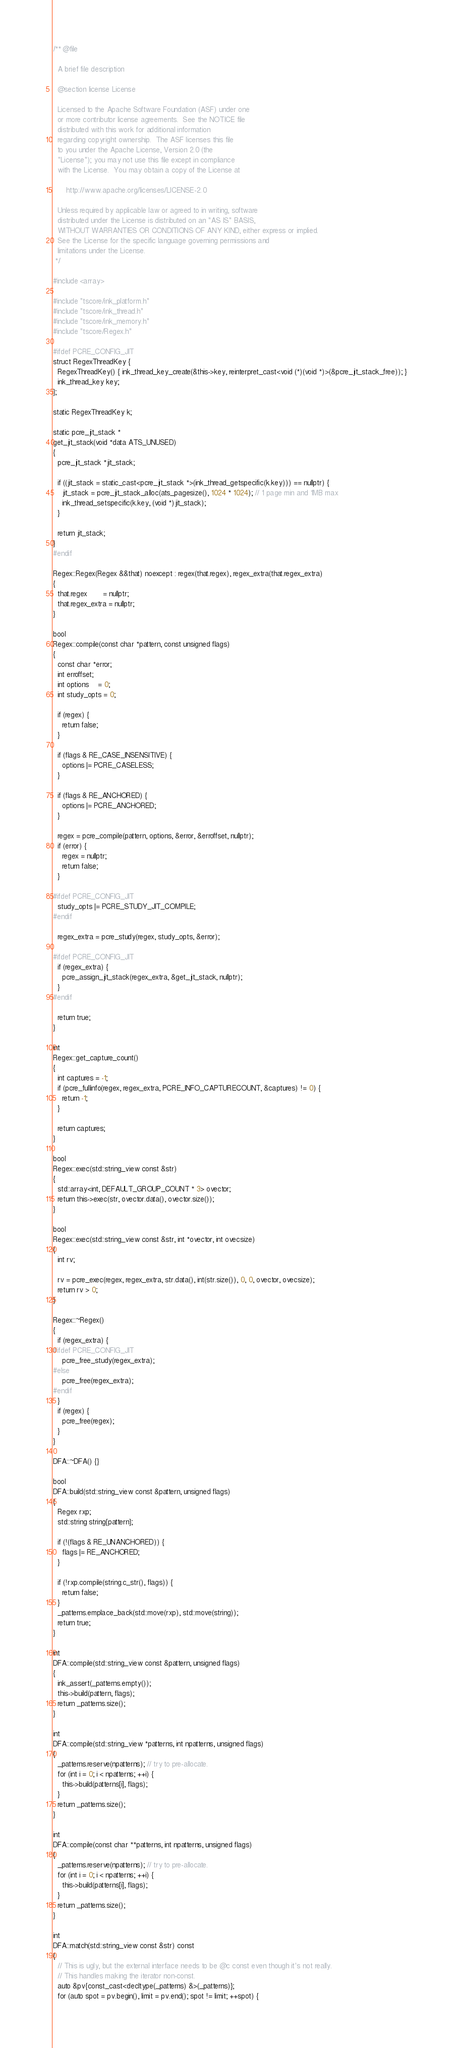<code> <loc_0><loc_0><loc_500><loc_500><_C++_>/** @file

  A brief file description

  @section license License

  Licensed to the Apache Software Foundation (ASF) under one
  or more contributor license agreements.  See the NOTICE file
  distributed with this work for additional information
  regarding copyright ownership.  The ASF licenses this file
  to you under the Apache License, Version 2.0 (the
  "License"); you may not use this file except in compliance
  with the License.  You may obtain a copy of the License at

      http://www.apache.org/licenses/LICENSE-2.0

  Unless required by applicable law or agreed to in writing, software
  distributed under the License is distributed on an "AS IS" BASIS,
  WITHOUT WARRANTIES OR CONDITIONS OF ANY KIND, either express or implied.
  See the License for the specific language governing permissions and
  limitations under the License.
 */

#include <array>

#include "tscore/ink_platform.h"
#include "tscore/ink_thread.h"
#include "tscore/ink_memory.h"
#include "tscore/Regex.h"

#ifdef PCRE_CONFIG_JIT
struct RegexThreadKey {
  RegexThreadKey() { ink_thread_key_create(&this->key, reinterpret_cast<void (*)(void *)>(&pcre_jit_stack_free)); }
  ink_thread_key key;
};

static RegexThreadKey k;

static pcre_jit_stack *
get_jit_stack(void *data ATS_UNUSED)
{
  pcre_jit_stack *jit_stack;

  if ((jit_stack = static_cast<pcre_jit_stack *>(ink_thread_getspecific(k.key))) == nullptr) {
    jit_stack = pcre_jit_stack_alloc(ats_pagesize(), 1024 * 1024); // 1 page min and 1MB max
    ink_thread_setspecific(k.key, (void *)jit_stack);
  }

  return jit_stack;
}
#endif

Regex::Regex(Regex &&that) noexcept : regex(that.regex), regex_extra(that.regex_extra)
{
  that.regex       = nullptr;
  that.regex_extra = nullptr;
}

bool
Regex::compile(const char *pattern, const unsigned flags)
{
  const char *error;
  int erroffset;
  int options    = 0;
  int study_opts = 0;

  if (regex) {
    return false;
  }

  if (flags & RE_CASE_INSENSITIVE) {
    options |= PCRE_CASELESS;
  }

  if (flags & RE_ANCHORED) {
    options |= PCRE_ANCHORED;
  }

  regex = pcre_compile(pattern, options, &error, &erroffset, nullptr);
  if (error) {
    regex = nullptr;
    return false;
  }

#ifdef PCRE_CONFIG_JIT
  study_opts |= PCRE_STUDY_JIT_COMPILE;
#endif

  regex_extra = pcre_study(regex, study_opts, &error);

#ifdef PCRE_CONFIG_JIT
  if (regex_extra) {
    pcre_assign_jit_stack(regex_extra, &get_jit_stack, nullptr);
  }
#endif

  return true;
}

int
Regex::get_capture_count()
{
  int captures = -1;
  if (pcre_fullinfo(regex, regex_extra, PCRE_INFO_CAPTURECOUNT, &captures) != 0) {
    return -1;
  }

  return captures;
}

bool
Regex::exec(std::string_view const &str)
{
  std::array<int, DEFAULT_GROUP_COUNT * 3> ovector;
  return this->exec(str, ovector.data(), ovector.size());
}

bool
Regex::exec(std::string_view const &str, int *ovector, int ovecsize)
{
  int rv;

  rv = pcre_exec(regex, regex_extra, str.data(), int(str.size()), 0, 0, ovector, ovecsize);
  return rv > 0;
}

Regex::~Regex()
{
  if (regex_extra) {
#ifdef PCRE_CONFIG_JIT
    pcre_free_study(regex_extra);
#else
    pcre_free(regex_extra);
#endif
  }
  if (regex) {
    pcre_free(regex);
  }
}

DFA::~DFA() {}

bool
DFA::build(std::string_view const &pattern, unsigned flags)
{
  Regex rxp;
  std::string string{pattern};

  if (!(flags & RE_UNANCHORED)) {
    flags |= RE_ANCHORED;
  }

  if (!rxp.compile(string.c_str(), flags)) {
    return false;
  }
  _patterns.emplace_back(std::move(rxp), std::move(string));
  return true;
}

int
DFA::compile(std::string_view const &pattern, unsigned flags)
{
  ink_assert(_patterns.empty());
  this->build(pattern, flags);
  return _patterns.size();
}

int
DFA::compile(std::string_view *patterns, int npatterns, unsigned flags)
{
  _patterns.reserve(npatterns); // try to pre-allocate.
  for (int i = 0; i < npatterns; ++i) {
    this->build(patterns[i], flags);
  }
  return _patterns.size();
}

int
DFA::compile(const char **patterns, int npatterns, unsigned flags)
{
  _patterns.reserve(npatterns); // try to pre-allocate.
  for (int i = 0; i < npatterns; ++i) {
    this->build(patterns[i], flags);
  }
  return _patterns.size();
}

int
DFA::match(std::string_view const &str) const
{
  // This is ugly, but the external interface needs to be @c const even though it's not really.
  // This handles making the iterator non-const.
  auto &pv{const_cast<decltype(_patterns) &>(_patterns)};
  for (auto spot = pv.begin(), limit = pv.end(); spot != limit; ++spot) {</code> 